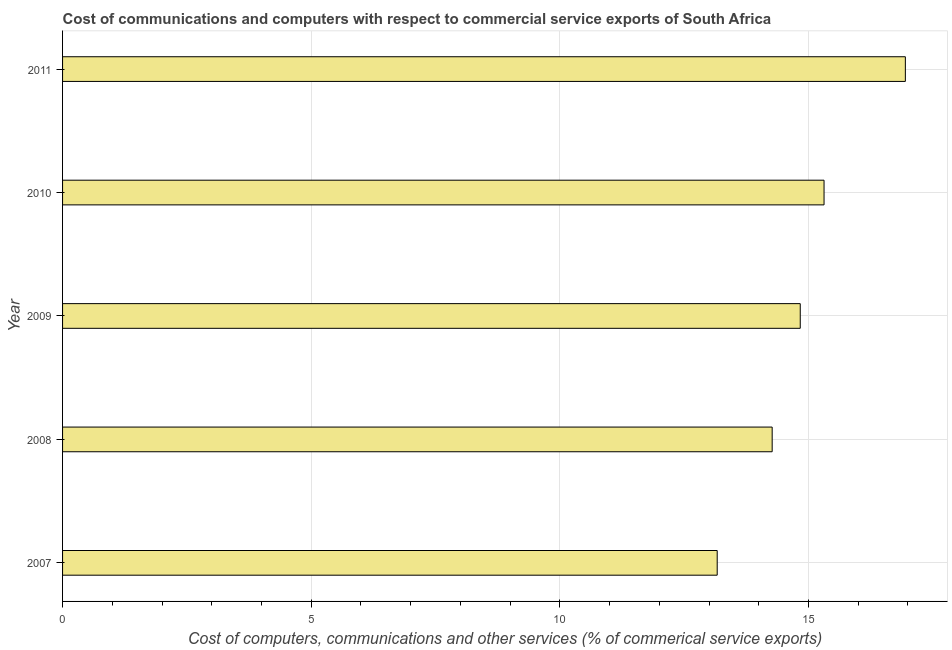What is the title of the graph?
Your answer should be very brief. Cost of communications and computers with respect to commercial service exports of South Africa. What is the label or title of the X-axis?
Your response must be concise. Cost of computers, communications and other services (% of commerical service exports). What is the label or title of the Y-axis?
Provide a succinct answer. Year. What is the  computer and other services in 2007?
Offer a very short reply. 13.17. Across all years, what is the maximum  computer and other services?
Your answer should be compact. 16.95. Across all years, what is the minimum  computer and other services?
Your response must be concise. 13.17. In which year was the cost of communications minimum?
Ensure brevity in your answer.  2007. What is the sum of the  computer and other services?
Provide a succinct answer. 74.53. What is the difference between the  computer and other services in 2010 and 2011?
Give a very brief answer. -1.64. What is the average  computer and other services per year?
Your answer should be compact. 14.91. What is the median  computer and other services?
Offer a terse response. 14.84. In how many years, is the  computer and other services greater than 3 %?
Give a very brief answer. 5. What is the ratio of the cost of communications in 2009 to that in 2011?
Provide a short and direct response. 0.88. What is the difference between the highest and the second highest cost of communications?
Provide a short and direct response. 1.64. Is the sum of the cost of communications in 2007 and 2009 greater than the maximum cost of communications across all years?
Provide a succinct answer. Yes. What is the difference between the highest and the lowest cost of communications?
Offer a terse response. 3.78. In how many years, is the cost of communications greater than the average cost of communications taken over all years?
Offer a very short reply. 2. What is the Cost of computers, communications and other services (% of commerical service exports) in 2007?
Offer a terse response. 13.17. What is the Cost of computers, communications and other services (% of commerical service exports) of 2008?
Give a very brief answer. 14.27. What is the Cost of computers, communications and other services (% of commerical service exports) in 2009?
Ensure brevity in your answer.  14.84. What is the Cost of computers, communications and other services (% of commerical service exports) in 2010?
Make the answer very short. 15.31. What is the Cost of computers, communications and other services (% of commerical service exports) of 2011?
Your response must be concise. 16.95. What is the difference between the Cost of computers, communications and other services (% of commerical service exports) in 2007 and 2008?
Your answer should be compact. -1.11. What is the difference between the Cost of computers, communications and other services (% of commerical service exports) in 2007 and 2009?
Keep it short and to the point. -1.67. What is the difference between the Cost of computers, communications and other services (% of commerical service exports) in 2007 and 2010?
Provide a short and direct response. -2.15. What is the difference between the Cost of computers, communications and other services (% of commerical service exports) in 2007 and 2011?
Provide a short and direct response. -3.78. What is the difference between the Cost of computers, communications and other services (% of commerical service exports) in 2008 and 2009?
Keep it short and to the point. -0.56. What is the difference between the Cost of computers, communications and other services (% of commerical service exports) in 2008 and 2010?
Provide a succinct answer. -1.04. What is the difference between the Cost of computers, communications and other services (% of commerical service exports) in 2008 and 2011?
Your answer should be very brief. -2.68. What is the difference between the Cost of computers, communications and other services (% of commerical service exports) in 2009 and 2010?
Ensure brevity in your answer.  -0.48. What is the difference between the Cost of computers, communications and other services (% of commerical service exports) in 2009 and 2011?
Offer a very short reply. -2.11. What is the difference between the Cost of computers, communications and other services (% of commerical service exports) in 2010 and 2011?
Make the answer very short. -1.64. What is the ratio of the Cost of computers, communications and other services (% of commerical service exports) in 2007 to that in 2008?
Your answer should be very brief. 0.92. What is the ratio of the Cost of computers, communications and other services (% of commerical service exports) in 2007 to that in 2009?
Ensure brevity in your answer.  0.89. What is the ratio of the Cost of computers, communications and other services (% of commerical service exports) in 2007 to that in 2010?
Keep it short and to the point. 0.86. What is the ratio of the Cost of computers, communications and other services (% of commerical service exports) in 2007 to that in 2011?
Offer a very short reply. 0.78. What is the ratio of the Cost of computers, communications and other services (% of commerical service exports) in 2008 to that in 2010?
Your answer should be very brief. 0.93. What is the ratio of the Cost of computers, communications and other services (% of commerical service exports) in 2008 to that in 2011?
Provide a short and direct response. 0.84. What is the ratio of the Cost of computers, communications and other services (% of commerical service exports) in 2009 to that in 2010?
Make the answer very short. 0.97. What is the ratio of the Cost of computers, communications and other services (% of commerical service exports) in 2010 to that in 2011?
Offer a terse response. 0.9. 